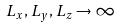Convert formula to latex. <formula><loc_0><loc_0><loc_500><loc_500>L _ { x } , L _ { y } , L _ { z } \rightarrow \infty</formula> 